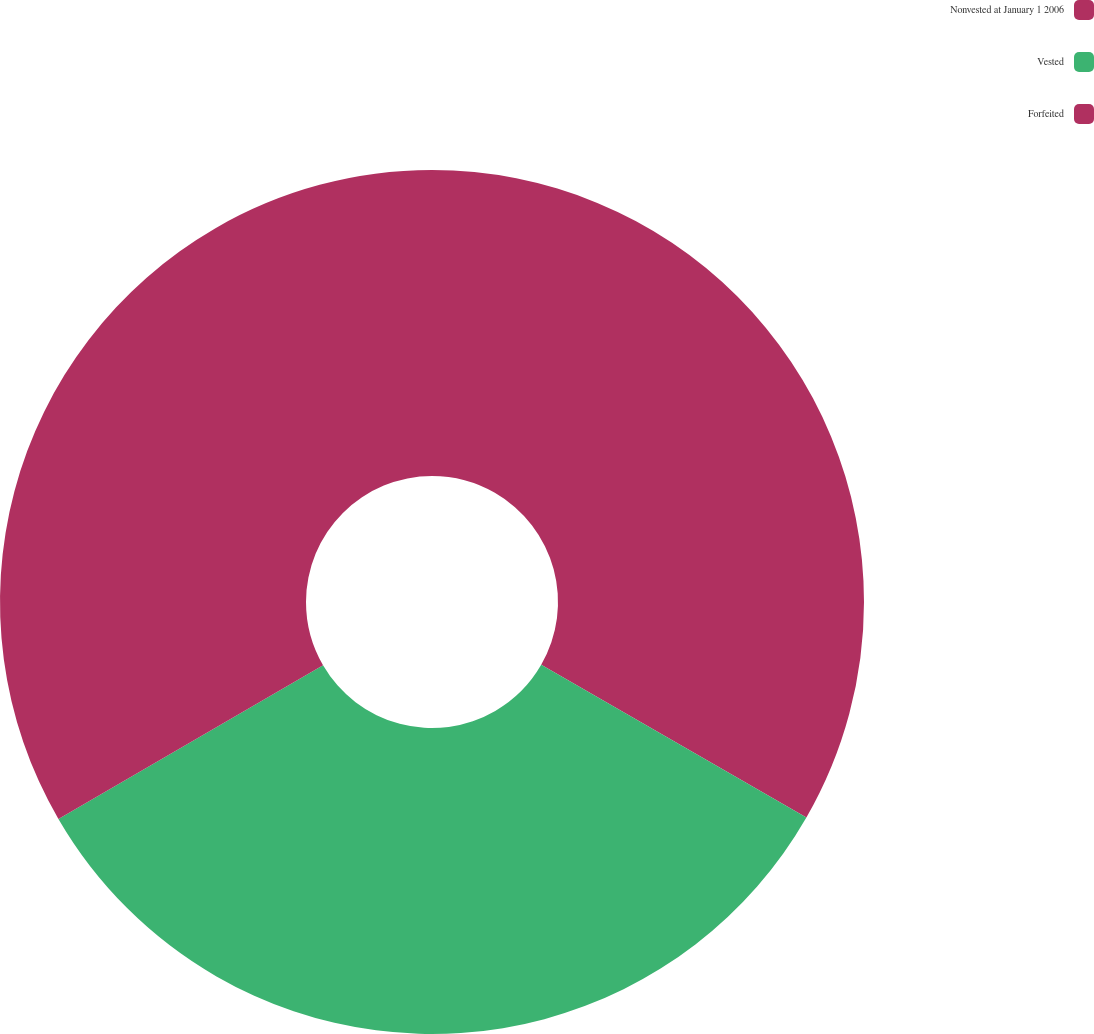<chart> <loc_0><loc_0><loc_500><loc_500><pie_chart><fcel>Nonvested at January 1 2006<fcel>Vested<fcel>Forfeited<nl><fcel>33.31%<fcel>33.31%<fcel>33.37%<nl></chart> 